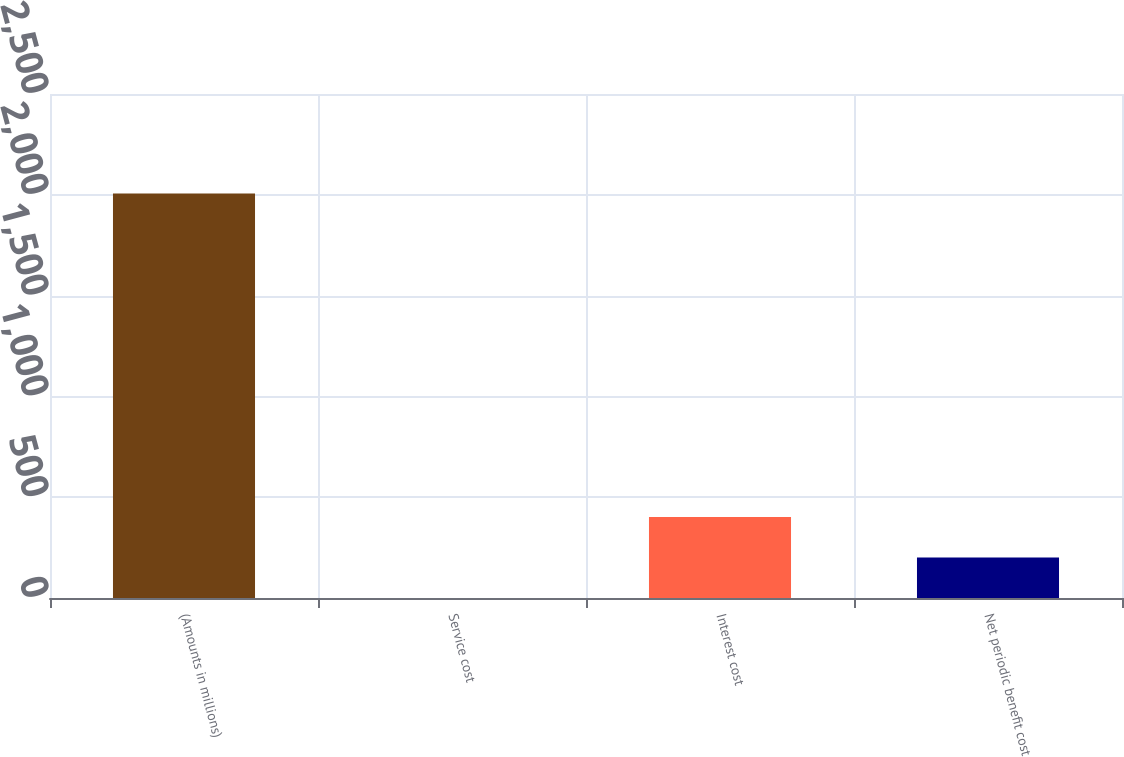Convert chart. <chart><loc_0><loc_0><loc_500><loc_500><bar_chart><fcel>(Amounts in millions)<fcel>Service cost<fcel>Interest cost<fcel>Net periodic benefit cost<nl><fcel>2006<fcel>0.5<fcel>401.6<fcel>201.05<nl></chart> 